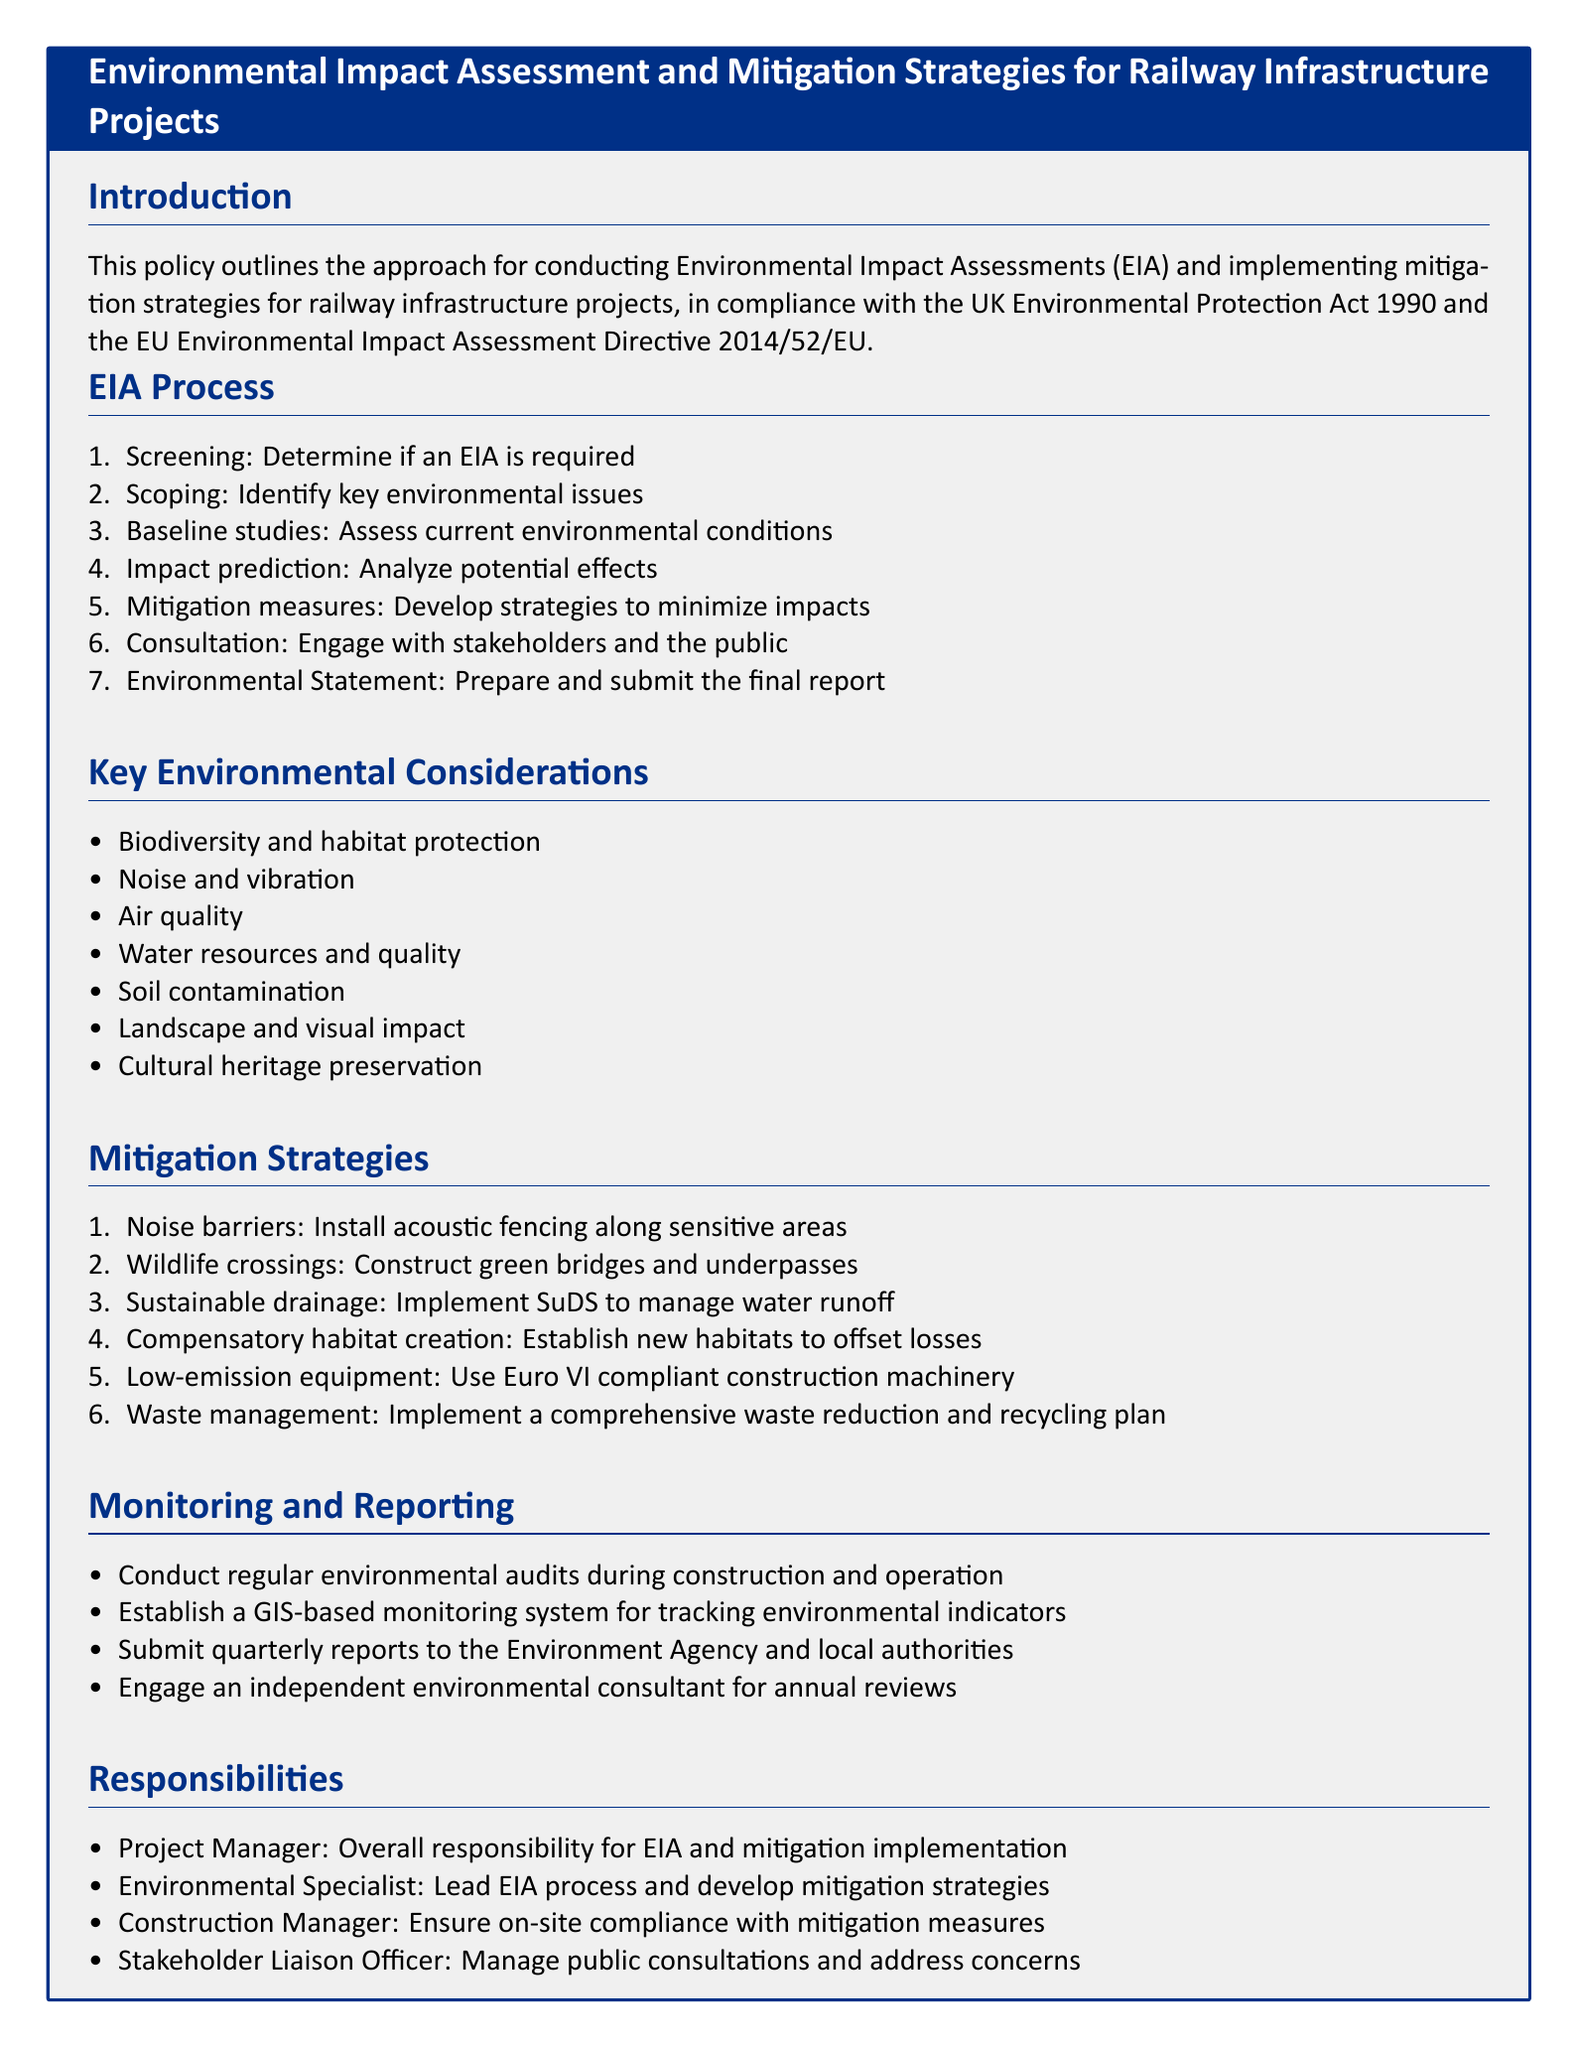What are the key environmental considerations? The key environmental considerations are listed in the document and include aspects that need to be addressed during the EIA process.
Answer: Biodiversity and habitat protection, Noise and vibration, Air quality, Water resources and quality, Soil contamination, Landscape and visual impact, Cultural heritage preservation What is the first step in the EIA process? The EIA process consists of several steps, and the first one is mentioned clearly in the document.
Answer: Screening What is the role of the Project Manager? The document outlines various responsibilities, including what is expected from the Project Manager during the EIA process.
Answer: Overall responsibility for EIA and mitigation implementation How often are reports submitted to the Environment Agency? The monitoring and reporting section specifies the frequency of reports sent to the authorities, providing clarity on reporting obligations.
Answer: Quarterly Which directive is mentioned in connection with EIA compliance? The document refers to specific legal frameworks that guide the EIA process, including a directive from the EU, which is crucial for context.
Answer: EU Environmental Impact Assessment Directive 2014/52/EU What mitigation strategy is recommended for managing noise? The document outlines specific strategies for mitigating various impacts during railway infrastructure projects, including noise management solutions.
Answer: Noise barriers What tool is suggested for monitoring environmental indicators? The document mentions a specific technological approach to tracking environmental metrics, which highlights the monitoring strategy in place.
Answer: GIS-based monitoring system What is the purpose of the scoping step in the EIA process? This step is part of the EIA process aimed at identifying critical issues, which are outlined in the document as necessary for effective assessment.
Answer: Identify key environmental issues 